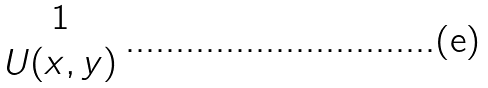Convert formula to latex. <formula><loc_0><loc_0><loc_500><loc_500>\begin{matrix} 1 \\ U ( x , y ) \end{matrix}</formula> 